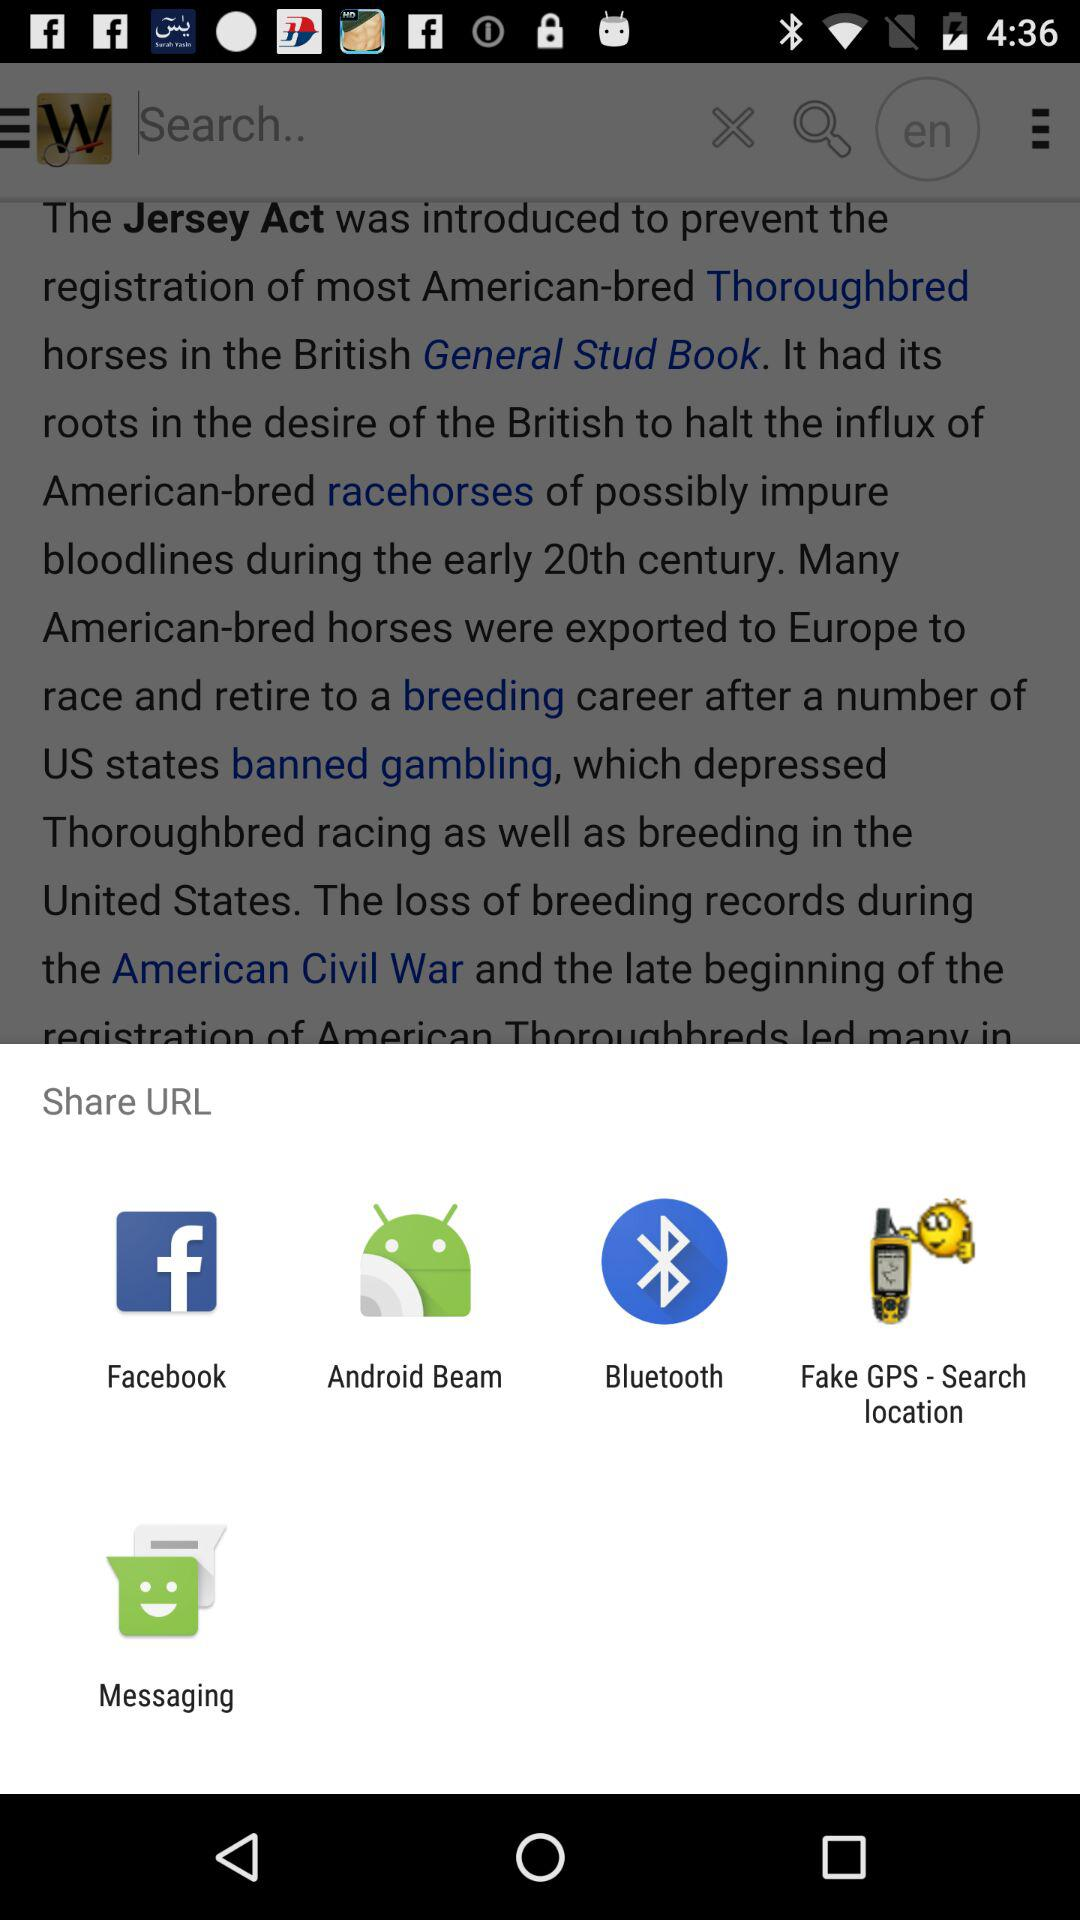Which are the different sharing options? The different sharing options are "Facebook", "Android Beam", "Bluetooth", "Fake GPS - Search location" and "Messaging". 